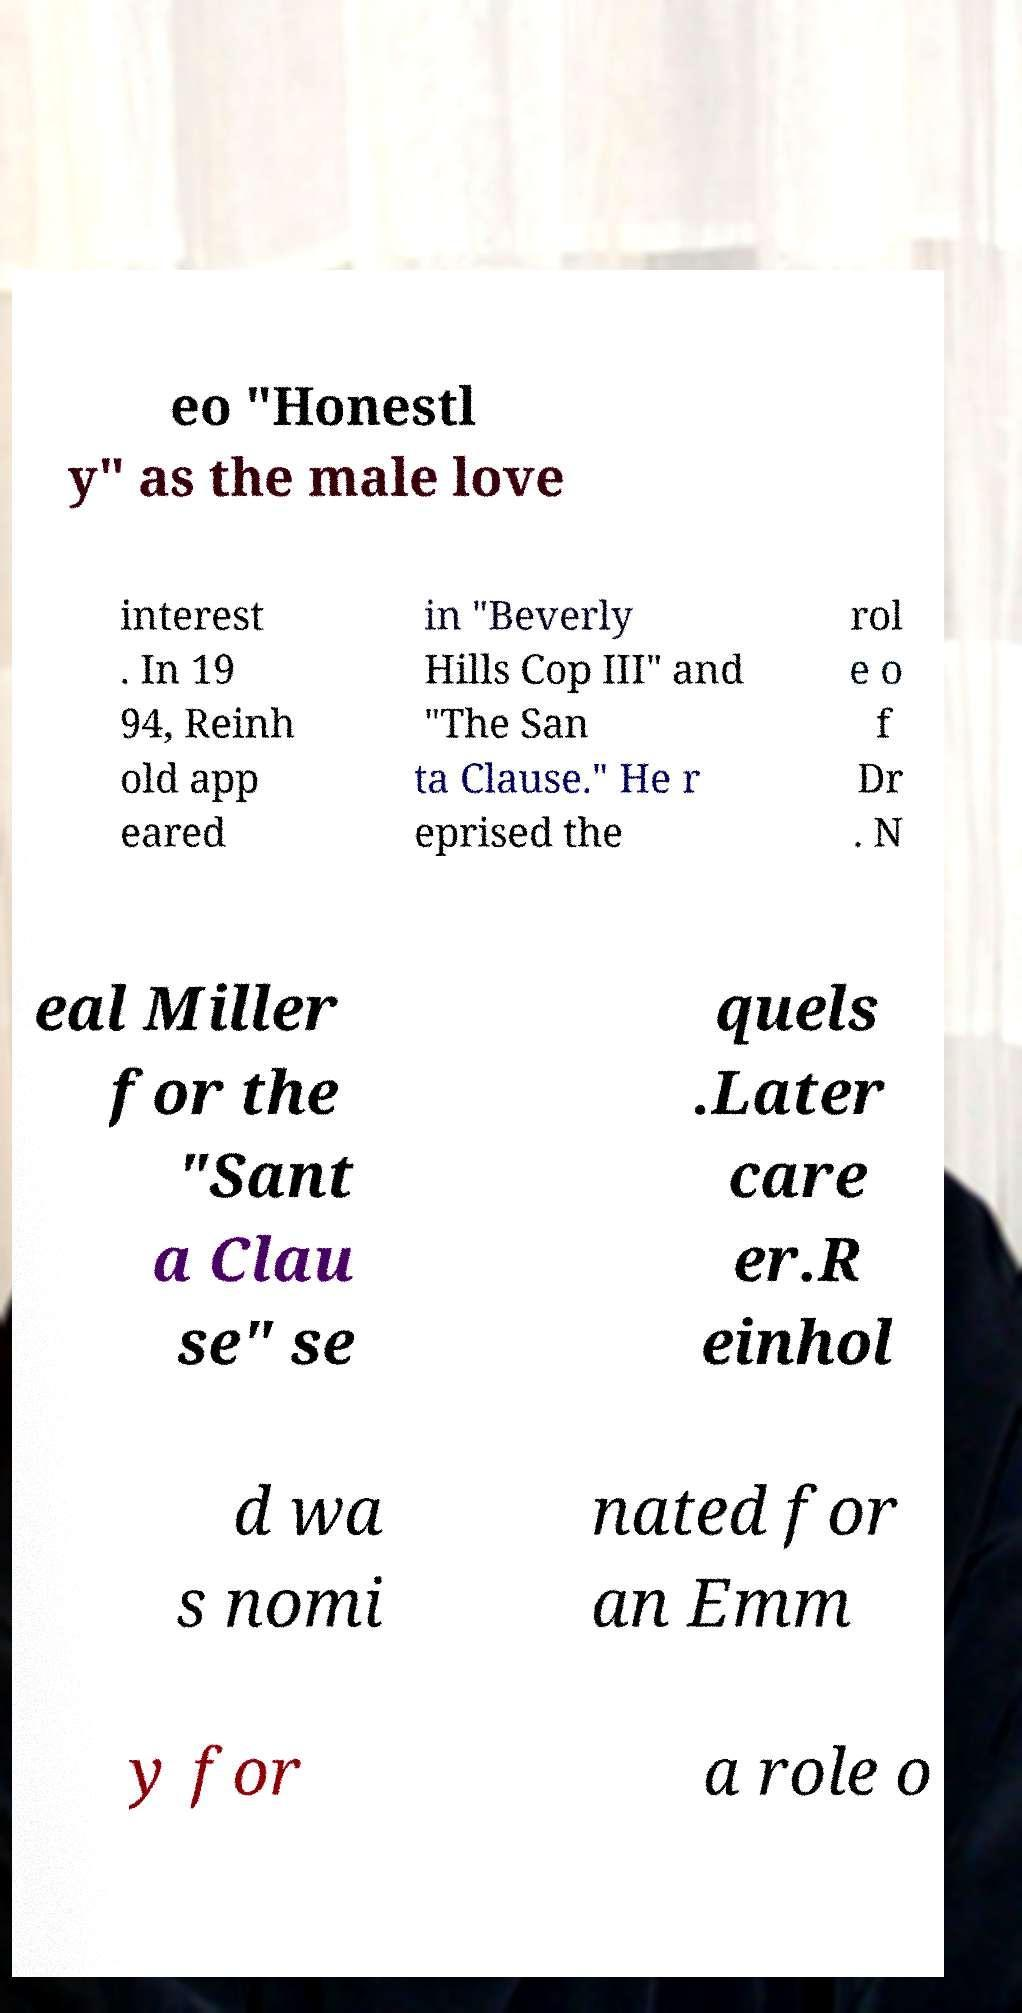Could you assist in decoding the text presented in this image and type it out clearly? eo "Honestl y" as the male love interest . In 19 94, Reinh old app eared in "Beverly Hills Cop III" and "The San ta Clause." He r eprised the rol e o f Dr . N eal Miller for the "Sant a Clau se" se quels .Later care er.R einhol d wa s nomi nated for an Emm y for a role o 